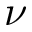Convert formula to latex. <formula><loc_0><loc_0><loc_500><loc_500>\nu</formula> 